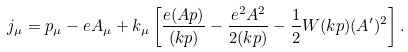Convert formula to latex. <formula><loc_0><loc_0><loc_500><loc_500>j _ { \mu } = p _ { \mu } - e A _ { \mu } + k _ { \mu } \left [ \frac { e ( A p ) } { ( k p ) } - \frac { e ^ { 2 } A ^ { 2 } } { 2 ( k p ) } - \frac { 1 } { 2 } W ( k p ) ( A ^ { \prime } ) ^ { 2 } \right ] .</formula> 